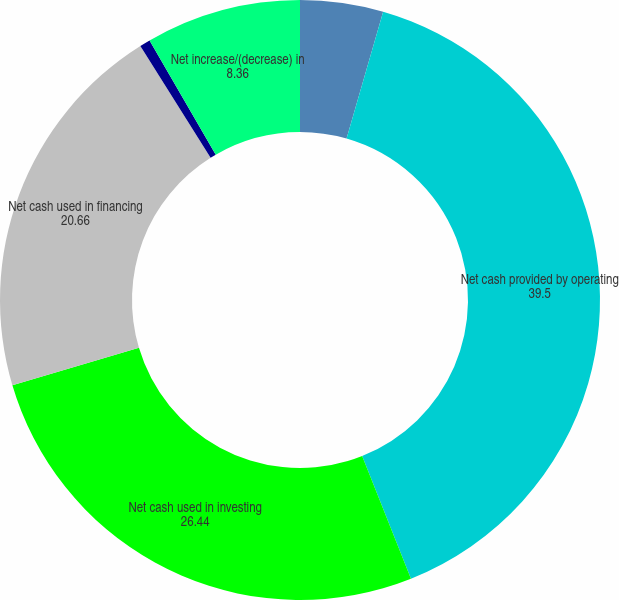<chart> <loc_0><loc_0><loc_500><loc_500><pie_chart><fcel>(in thousands)<fcel>Net cash provided by operating<fcel>Net cash used in investing<fcel>Net cash used in financing<fcel>Effect of exchange rate<fcel>Net increase/(decrease) in<nl><fcel>4.47%<fcel>39.5%<fcel>26.44%<fcel>20.66%<fcel>0.57%<fcel>8.36%<nl></chart> 